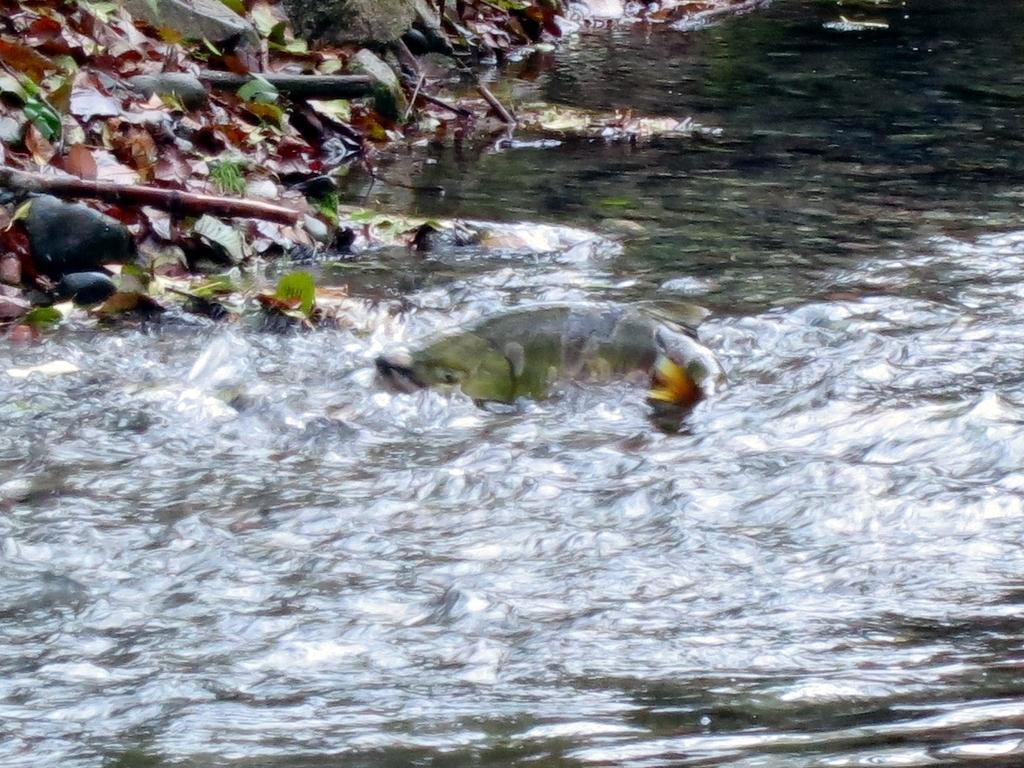Please provide a concise description of this image. In this image there is a fish in the water. On the top left side there are dry leaves, wooden sticks and some rocks. 